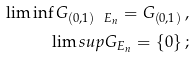Convert formula to latex. <formula><loc_0><loc_0><loc_500><loc_500>\liminf G _ { ( 0 , 1 ) \ E _ { n } } = G _ { ( 0 , 1 ) } \, , \\ \lim s u p G _ { E _ { n } } = \{ 0 \} \, ;</formula> 